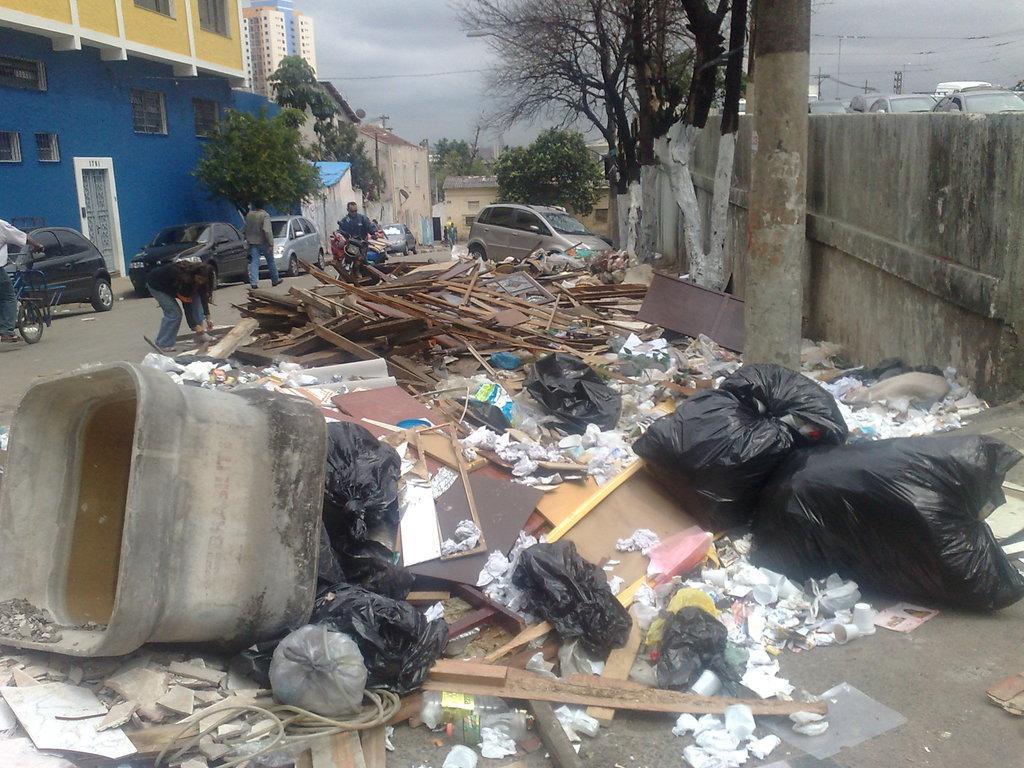Could you give a brief overview of what you see in this image? Here we can see garbage bags, container, trash, wall, pole and wooden sticks. Background we can see vehicles, poles, trees, people, sky and buildings. Sky is cloudy.  